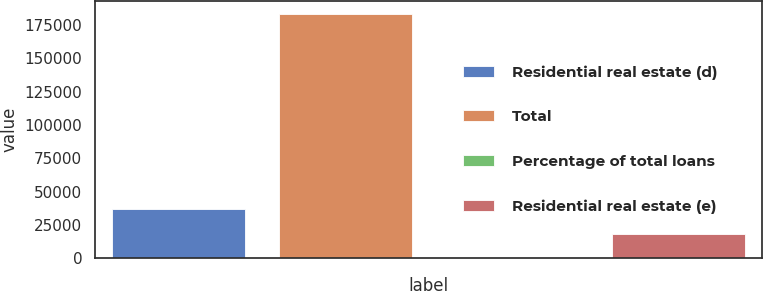<chart> <loc_0><loc_0><loc_500><loc_500><bar_chart><fcel>Residential real estate (d)<fcel>Total<fcel>Percentage of total loans<fcel>Residential real estate (e)<nl><fcel>36787.9<fcel>183564<fcel>93.83<fcel>18440.8<nl></chart> 